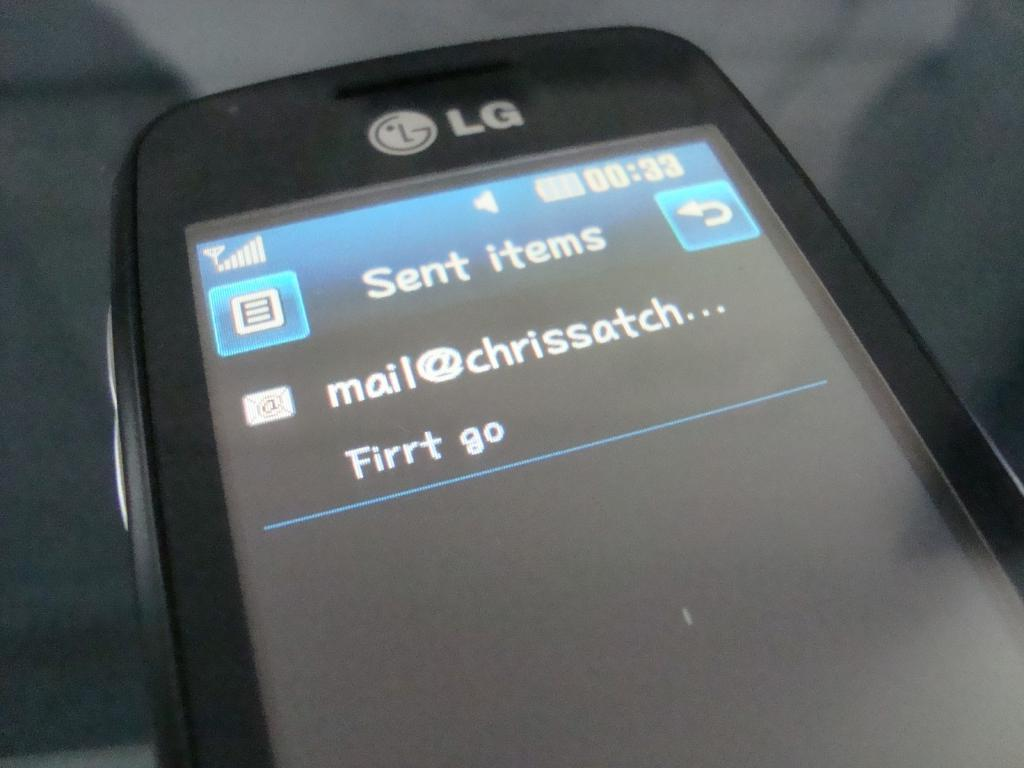<image>
Offer a succinct explanation of the picture presented. An LG phone shows a sent e-mail from mail@chrissatch. 